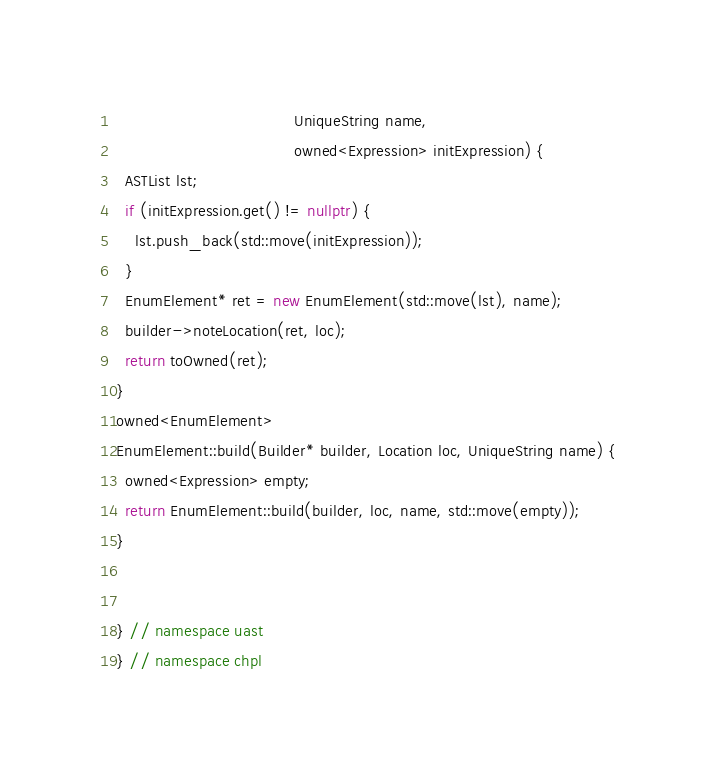<code> <loc_0><loc_0><loc_500><loc_500><_C++_>                                      UniqueString name,
                                      owned<Expression> initExpression) {
  ASTList lst;
  if (initExpression.get() != nullptr) {
    lst.push_back(std::move(initExpression));
  }
  EnumElement* ret = new EnumElement(std::move(lst), name);
  builder->noteLocation(ret, loc);
  return toOwned(ret);
}
owned<EnumElement>
EnumElement::build(Builder* builder, Location loc, UniqueString name) {
  owned<Expression> empty;
  return EnumElement::build(builder, loc, name, std::move(empty));
}
 

} // namespace uast
} // namespace chpl
</code> 